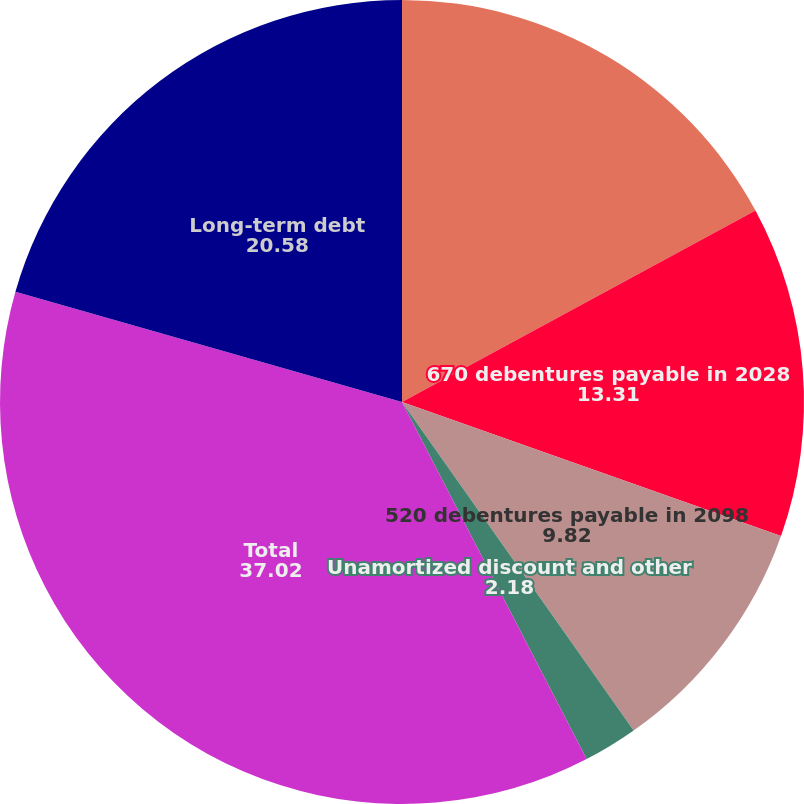Convert chart to OTSL. <chart><loc_0><loc_0><loc_500><loc_500><pie_chart><fcel>615 notes payable in 2008<fcel>670 debentures payable in 2028<fcel>520 debentures payable in 2098<fcel>Unamortized discount and other<fcel>Total<fcel>Long-term debt<nl><fcel>17.1%<fcel>13.31%<fcel>9.82%<fcel>2.18%<fcel>37.02%<fcel>20.58%<nl></chart> 